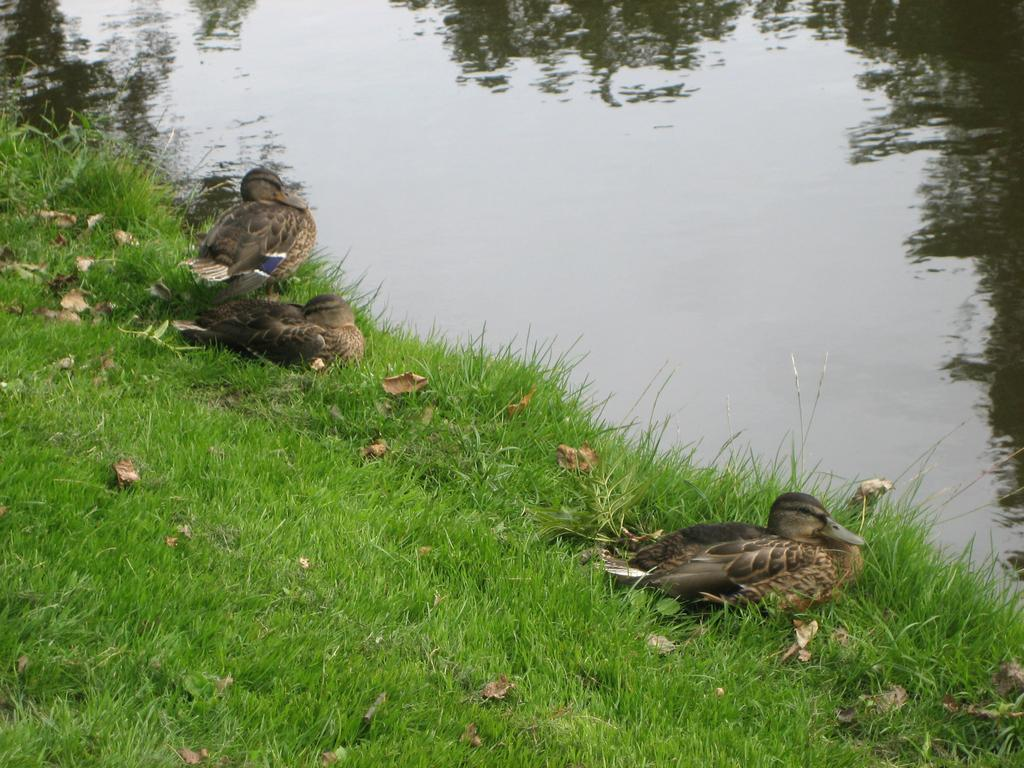What type of animals can be seen in the image? There are ducks in the image. Where are the ducks located? The ducks are sitting on the grass. What can be seen on the right side of the image? There is a canal visible on the right side of the image. What reason does the woman give for not feeding the ducks in the image? There is no woman present in the image, so it is not possible to determine any reasons for not feeding the ducks. 